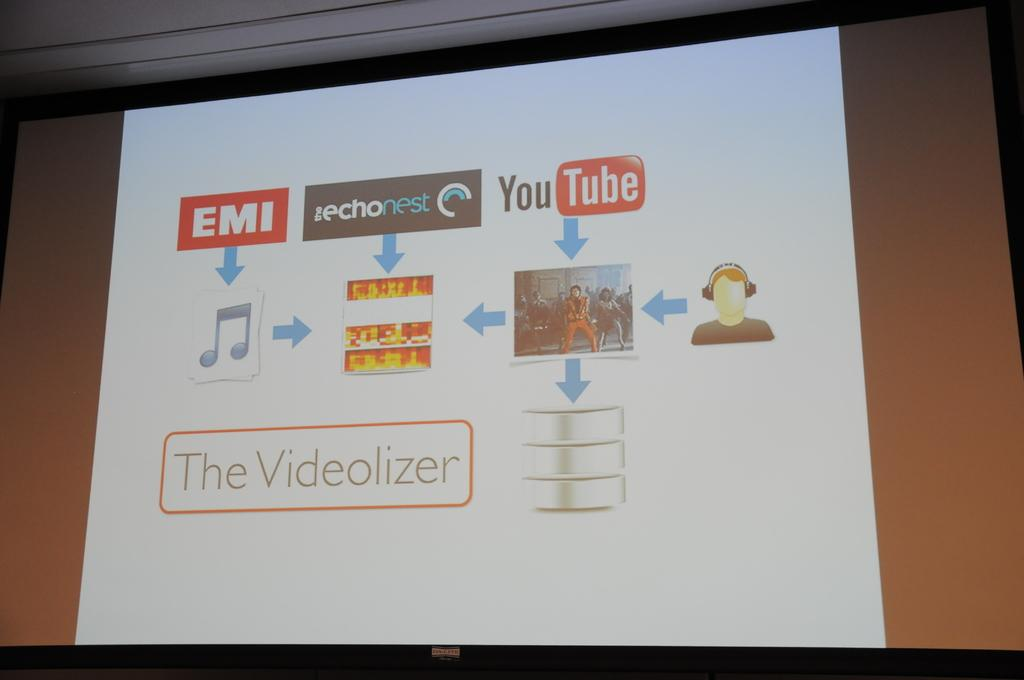What is the main object in the image? There is a big screen in the image. What is displayed on the screen? The screen displays an EMI icon, a YouTube icon, and a music icon. Is there a person visible on the screen? Yes, there is a person with headsets on the screen. Are there any directions or instructions on the screen? Yes, there are directions following these elements on the screen. What type of peace symbol can be seen in the image? There is no peace symbol present in the image. Can you describe the cellar in the image? There is no cellar present in the image; it features a big screen with various icons and a person with headsets. 